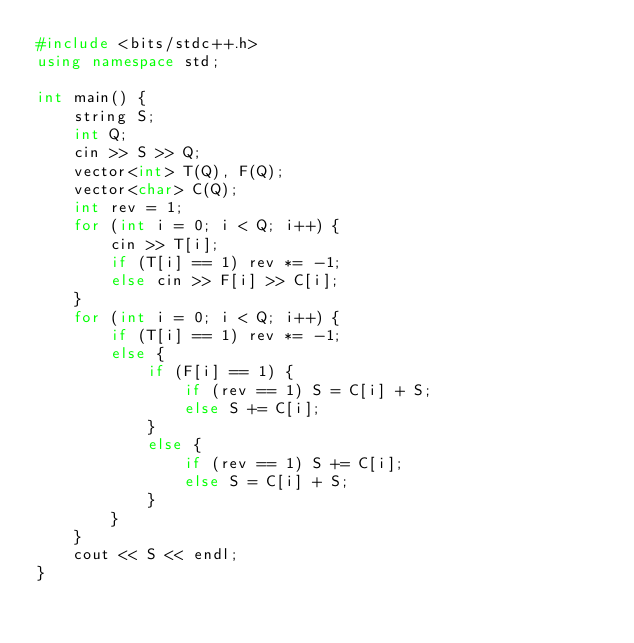<code> <loc_0><loc_0><loc_500><loc_500><_C++_>#include <bits/stdc++.h>
using namespace std;

int main() {
	string S;
	int Q;
	cin >> S >> Q;
	vector<int> T(Q), F(Q);
	vector<char> C(Q);
	int rev = 1;
	for (int i = 0; i < Q; i++) {
		cin >> T[i];
		if (T[i] == 1) rev *= -1;
		else cin >> F[i] >> C[i];
	}
	for (int i = 0; i < Q; i++) {
		if (T[i] == 1) rev *= -1;
		else {
			if (F[i] == 1) {
				if (rev == 1) S = C[i] + S;
				else S += C[i];
			}
			else {
				if (rev == 1) S += C[i];
				else S = C[i] + S;
			}
		}
	}
	cout << S << endl;
}</code> 